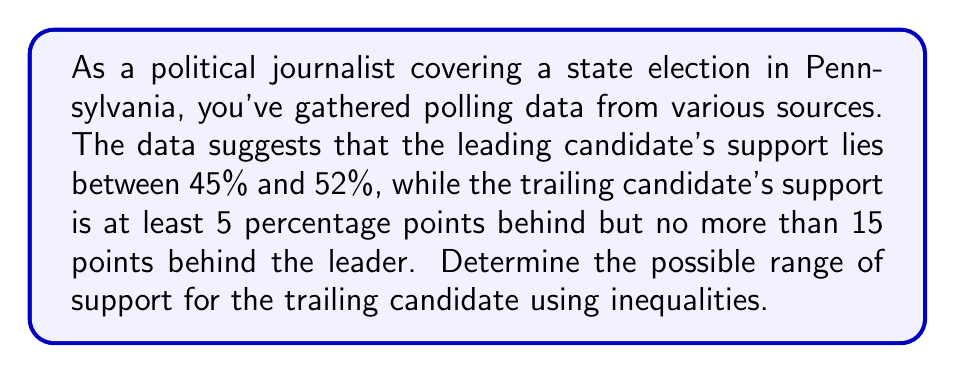Give your solution to this math problem. Let's approach this step-by-step:

1) Let $x$ represent the leading candidate's support percentage.
   Given information: $45 \leq x \leq 52$

2) Let $y$ represent the trailing candidate's support percentage.
   We know that $y$ is at least 5 points behind $x$, but no more than 15 points behind.
   This can be expressed as: $x - 15 \leq y \leq x - 5$

3) To find the range of $y$, we need to consider the minimum and maximum possible values:

   Minimum $y$:
   - Occurs when $x$ is at its minimum (45%) and the gap is at its maximum (15 points)
   - $y_{min} = 45 - 15 = 30$

   Maximum $y$:
   - Occurs when $x$ is at its maximum (52%) and the gap is at its minimum (5 points)
   - $y_{max} = 52 - 5 = 47$

4) Therefore, the range of support for the trailing candidate can be expressed as:

   $30 \leq y \leq 47$

This inequality represents all possible support percentages for the trailing candidate based on the given information.
Answer: The range of support for the trailing candidate is $30\% \leq y \leq 47\%$, where $y$ represents the trailing candidate's support percentage. 